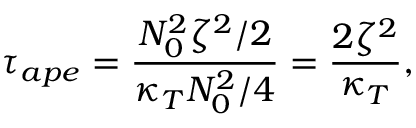<formula> <loc_0><loc_0><loc_500><loc_500>\tau _ { a p e } = \frac { N _ { 0 } ^ { 2 } \zeta ^ { 2 } / 2 } { \kappa _ { T } N _ { 0 } ^ { 2 } / 4 } = \frac { 2 \zeta ^ { 2 } } { \kappa _ { T } } ,</formula> 